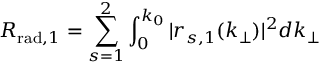Convert formula to latex. <formula><loc_0><loc_0><loc_500><loc_500>R _ { r a d , 1 } = \sum _ { s = 1 } ^ { 2 } \int _ { 0 } ^ { k _ { 0 } } | r _ { s , 1 } ( k _ { \perp } ) | ^ { 2 } d k _ { \perp }</formula> 